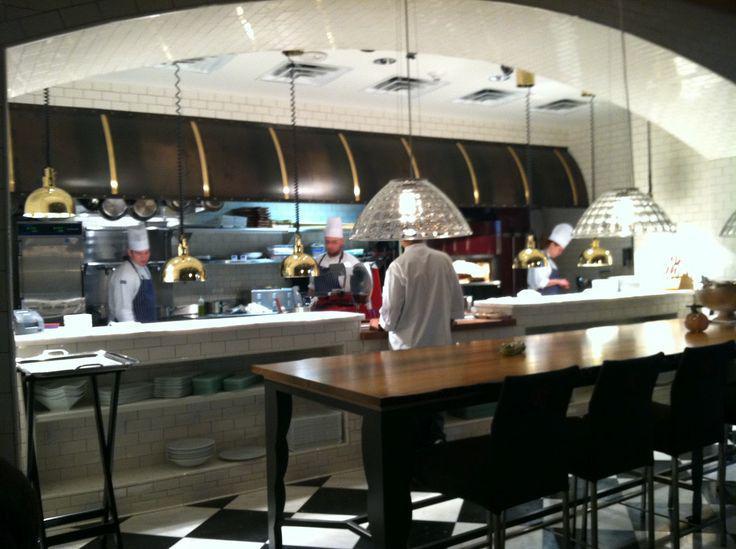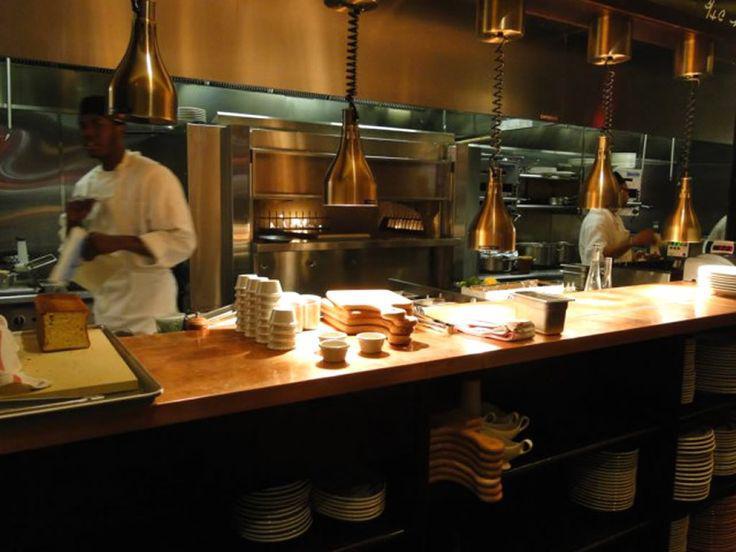The first image is the image on the left, the second image is the image on the right. Evaluate the accuracy of this statement regarding the images: "Each image contains restaurant employees". Is it true? Answer yes or no. Yes. The first image is the image on the left, the second image is the image on the right. Assess this claim about the two images: "People in white shirts are in front of and behind the long counter of an establishment with suspended glass lights in one image.". Correct or not? Answer yes or no. Yes. 